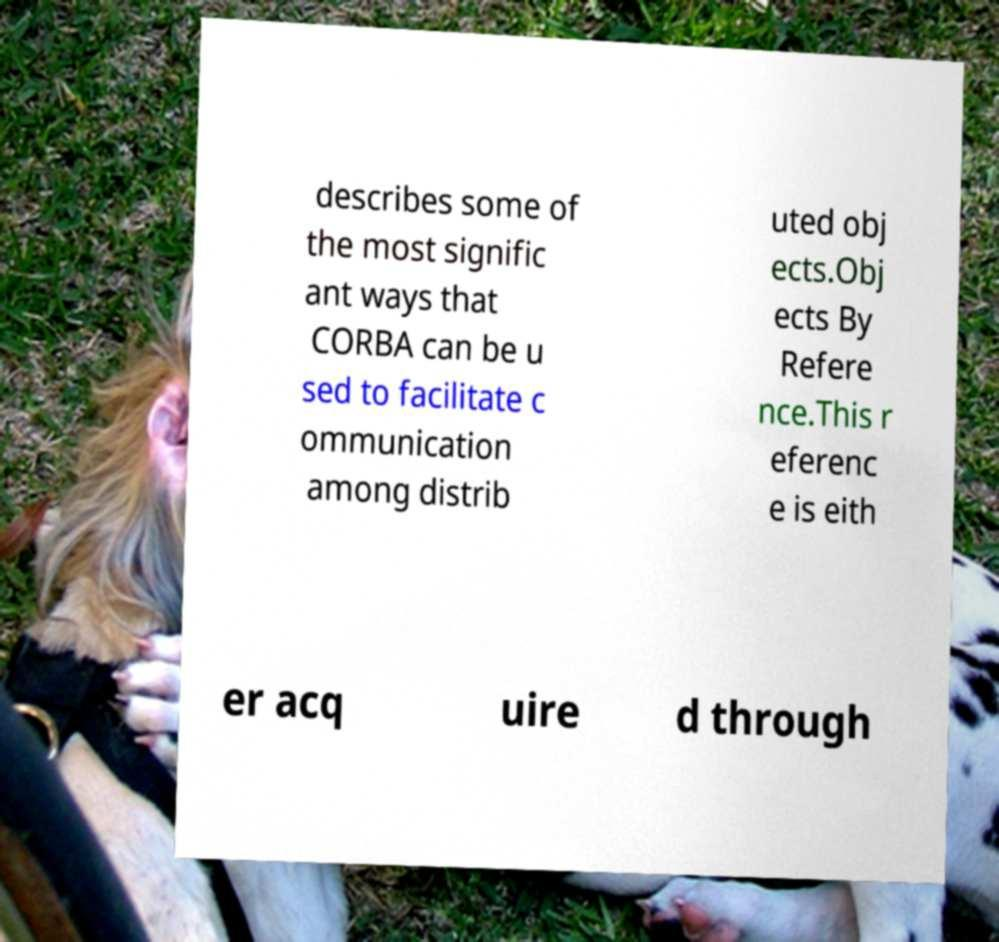Please identify and transcribe the text found in this image. describes some of the most signific ant ways that CORBA can be u sed to facilitate c ommunication among distrib uted obj ects.Obj ects By Refere nce.This r eferenc e is eith er acq uire d through 